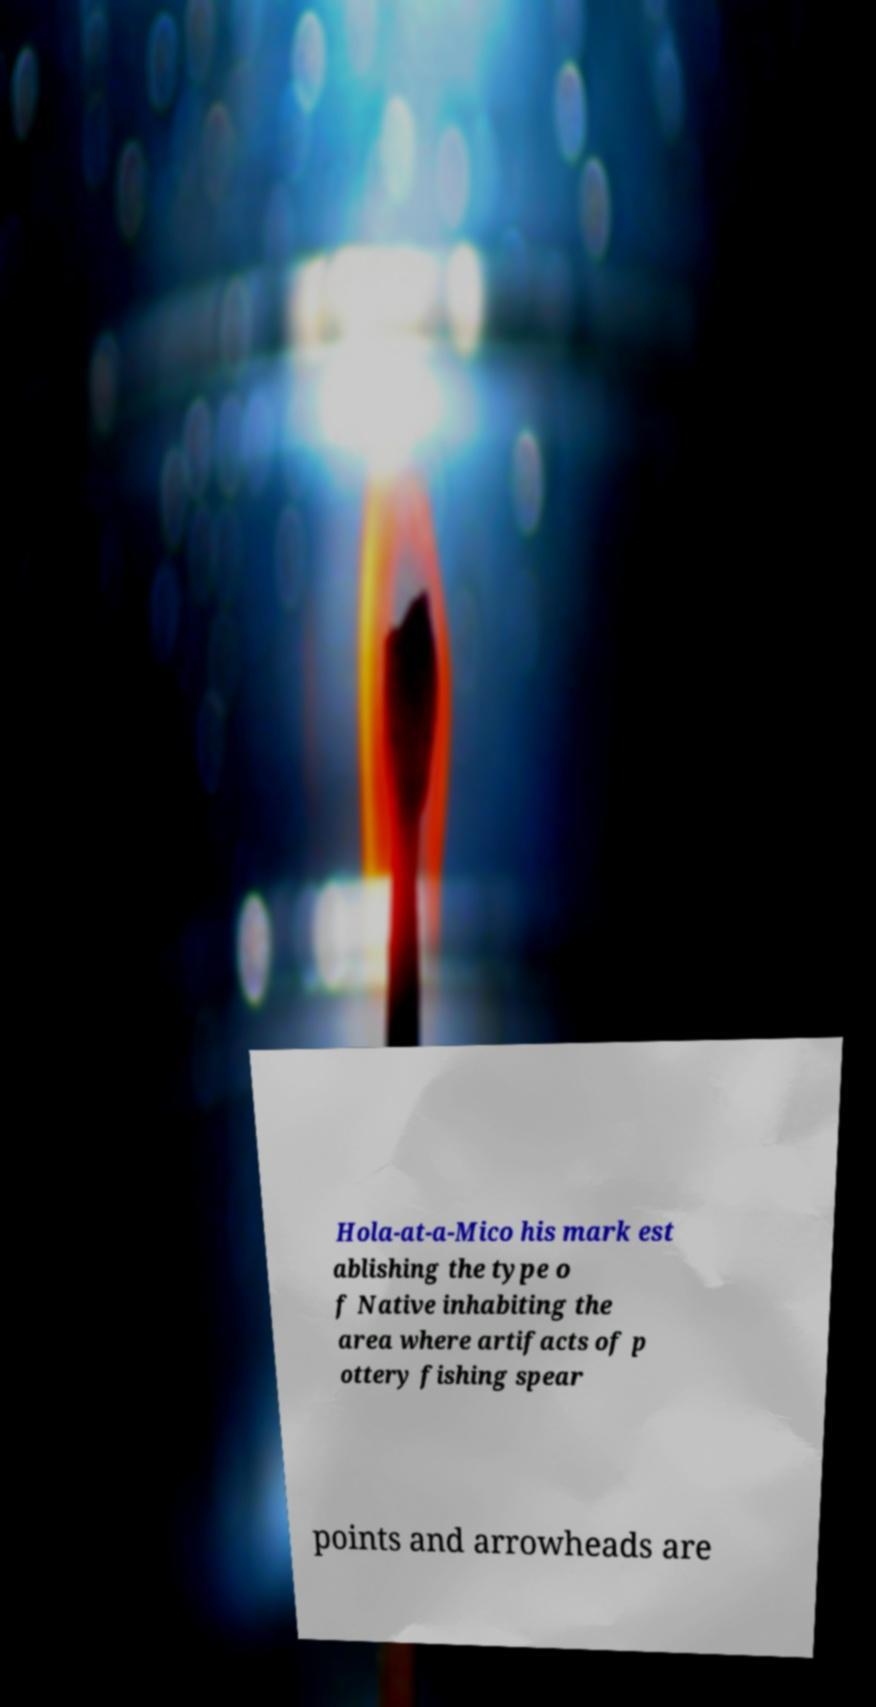For documentation purposes, I need the text within this image transcribed. Could you provide that? Hola-at-a-Mico his mark est ablishing the type o f Native inhabiting the area where artifacts of p ottery fishing spear points and arrowheads are 